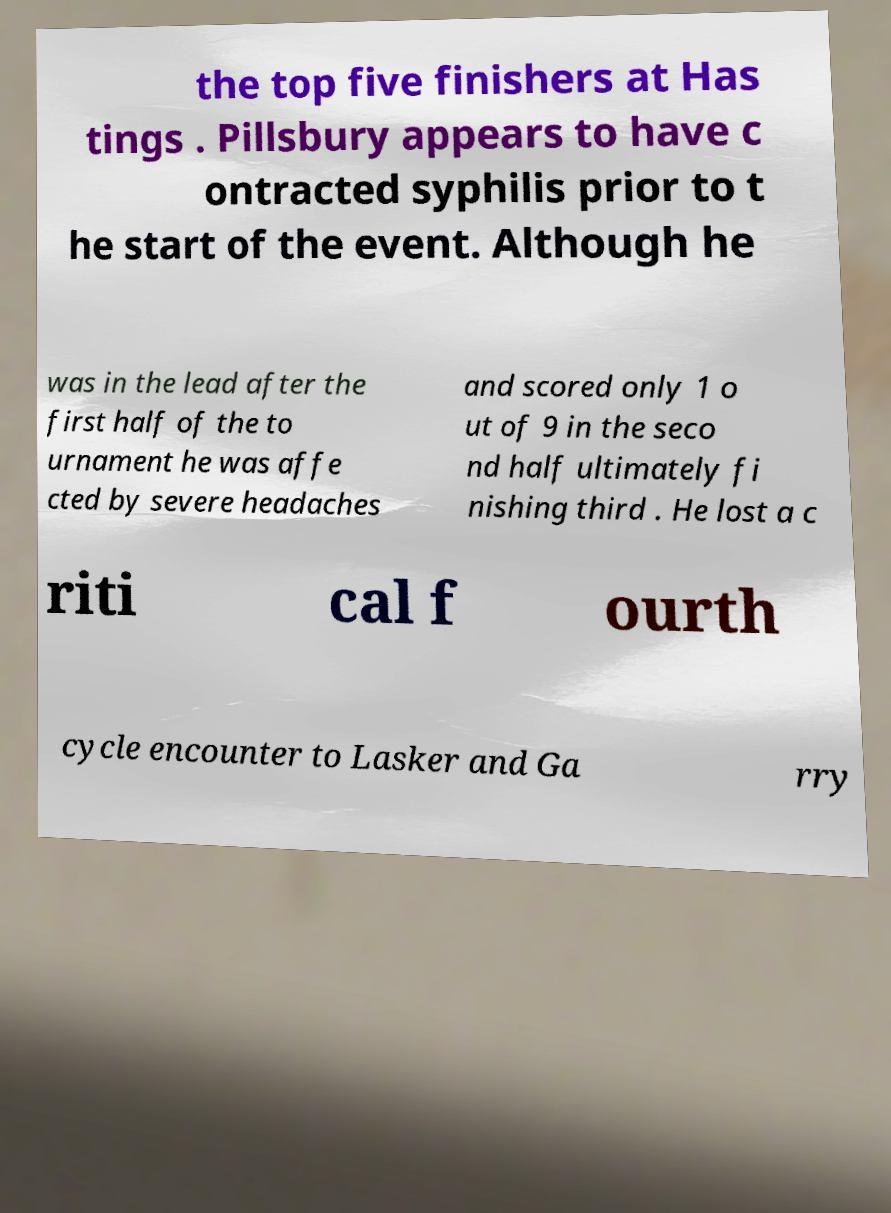What messages or text are displayed in this image? I need them in a readable, typed format. the top five finishers at Has tings . Pillsbury appears to have c ontracted syphilis prior to t he start of the event. Although he was in the lead after the first half of the to urnament he was affe cted by severe headaches and scored only 1 o ut of 9 in the seco nd half ultimately fi nishing third . He lost a c riti cal f ourth cycle encounter to Lasker and Ga rry 